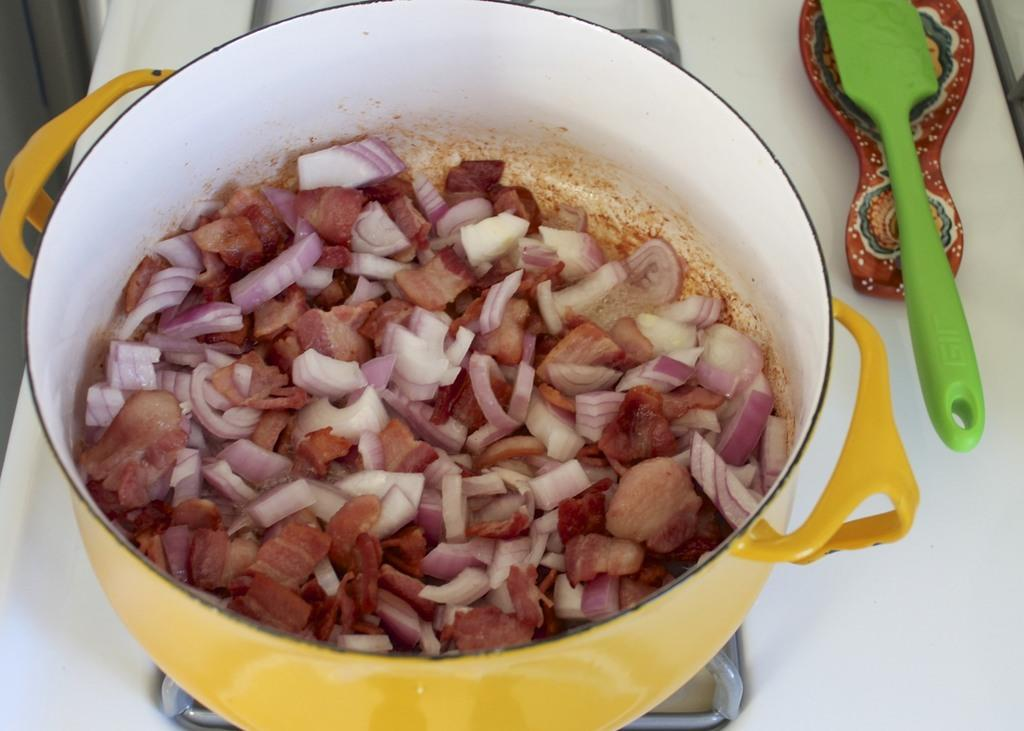What is on the stove in the image? There is a vessel with food items on the stove. Can you describe the objects placed on the white surface to the right side of the image? Unfortunately, the provided facts do not give any information about the objects placed on the white surface. How many boys are sitting at the secretary in the image? There is no secretary or boys present in the image. 